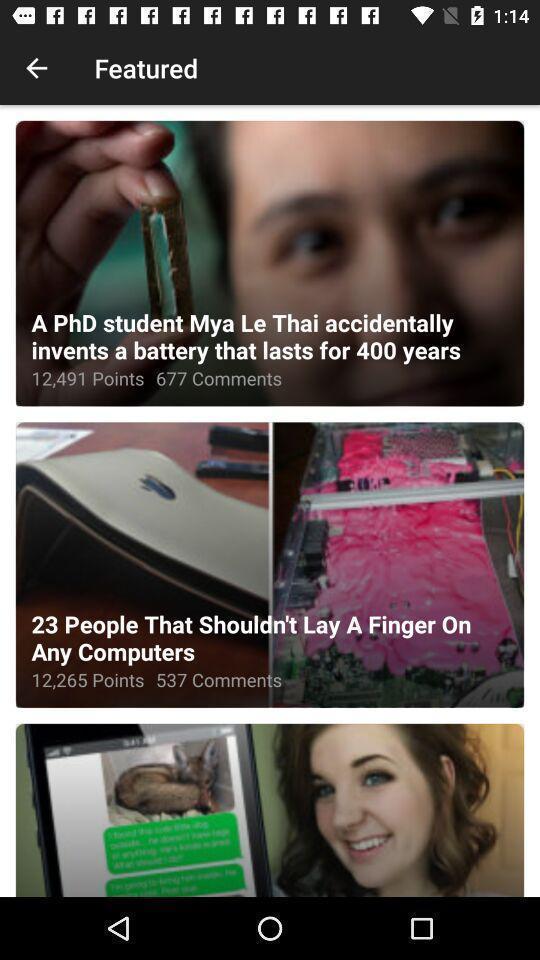Describe the key features of this screenshot. Page displayed different articles. 